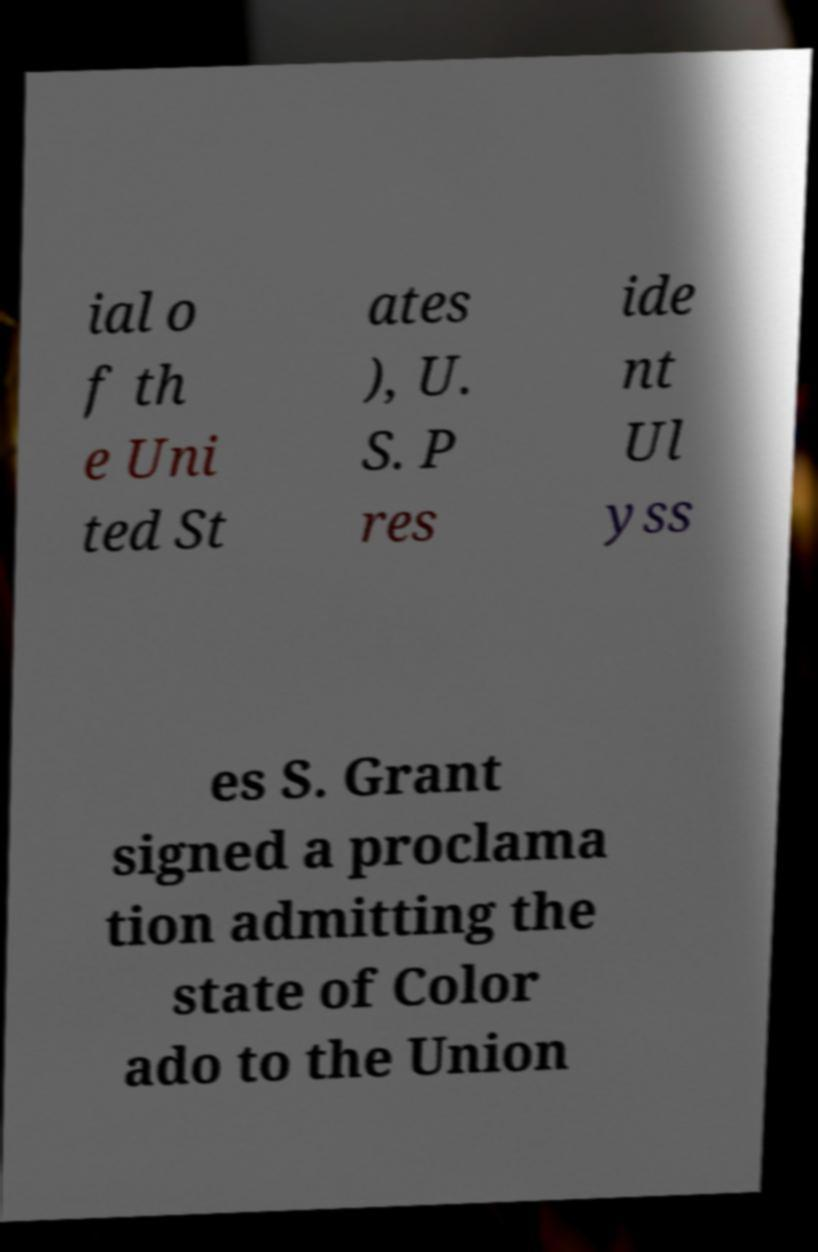Please read and relay the text visible in this image. What does it say? ial o f th e Uni ted St ates ), U. S. P res ide nt Ul yss es S. Grant signed a proclama tion admitting the state of Color ado to the Union 